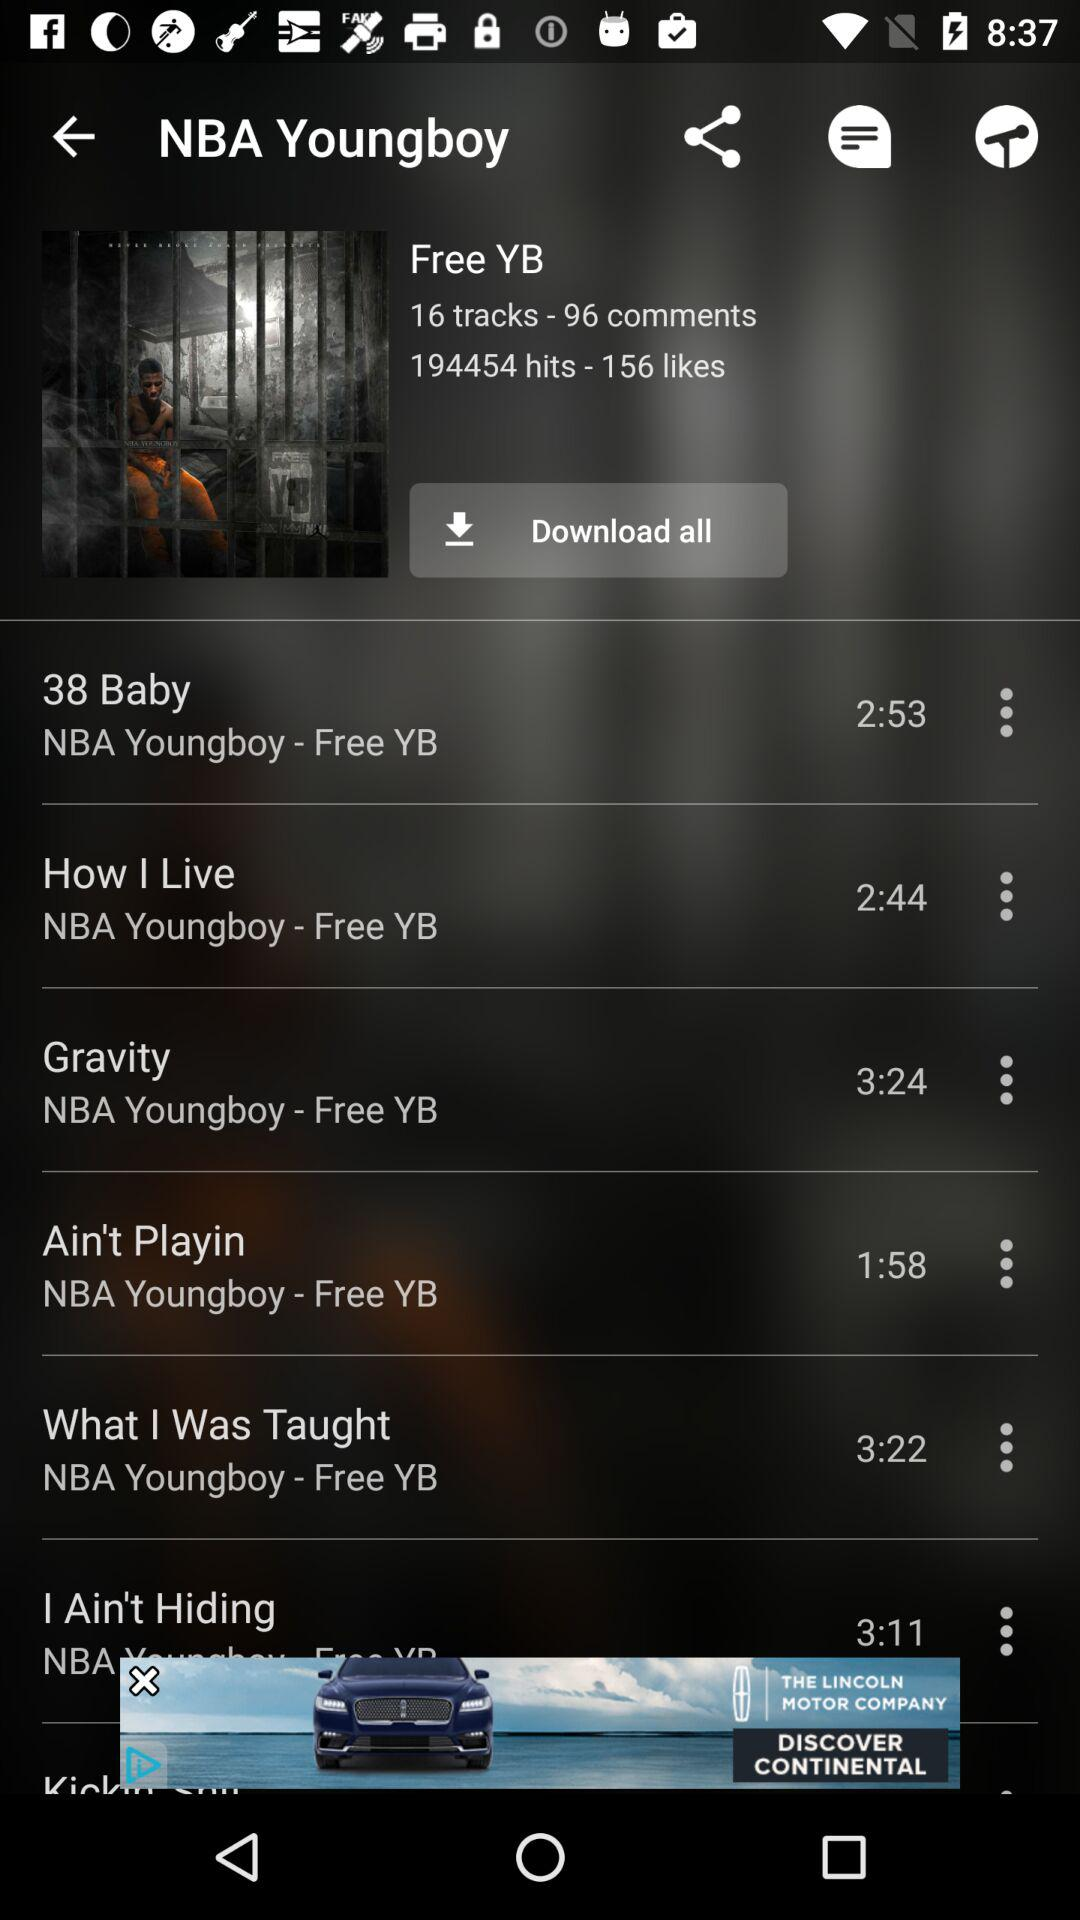What is the number of tracks? The number of tracks is 16. 